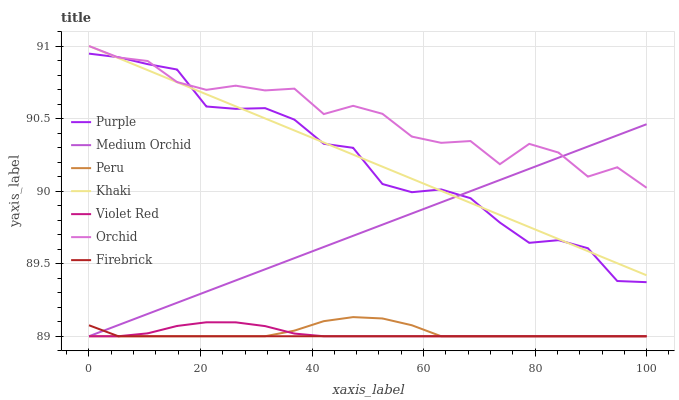Does Firebrick have the minimum area under the curve?
Answer yes or no. Yes. Does Orchid have the maximum area under the curve?
Answer yes or no. Yes. Does Khaki have the minimum area under the curve?
Answer yes or no. No. Does Khaki have the maximum area under the curve?
Answer yes or no. No. Is Medium Orchid the smoothest?
Answer yes or no. Yes. Is Orchid the roughest?
Answer yes or no. Yes. Is Khaki the smoothest?
Answer yes or no. No. Is Khaki the roughest?
Answer yes or no. No. Does Khaki have the lowest value?
Answer yes or no. No. Does Orchid have the highest value?
Answer yes or no. Yes. Does Purple have the highest value?
Answer yes or no. No. Is Firebrick less than Khaki?
Answer yes or no. Yes. Is Purple greater than Firebrick?
Answer yes or no. Yes. Does Medium Orchid intersect Firebrick?
Answer yes or no. Yes. Is Medium Orchid less than Firebrick?
Answer yes or no. No. Is Medium Orchid greater than Firebrick?
Answer yes or no. No. Does Firebrick intersect Khaki?
Answer yes or no. No. 